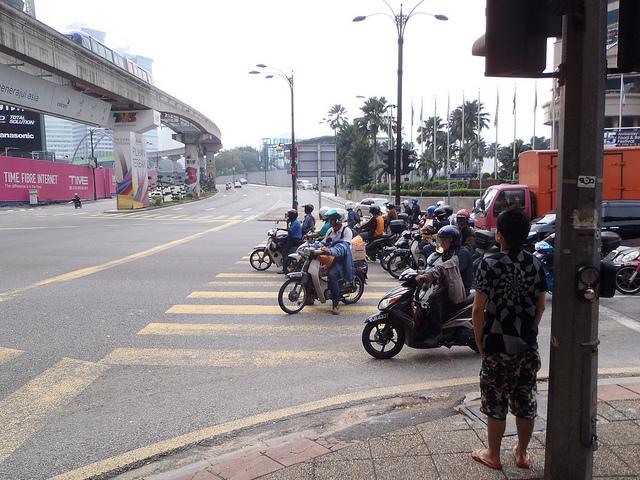What is the weather in this picture?
Quick response, please. Sunny. What kind of shoes is the standing person wearing?
Concise answer only. Flip flops. What type of vehicle is in the picture?
Concise answer only. Motorcycle. 